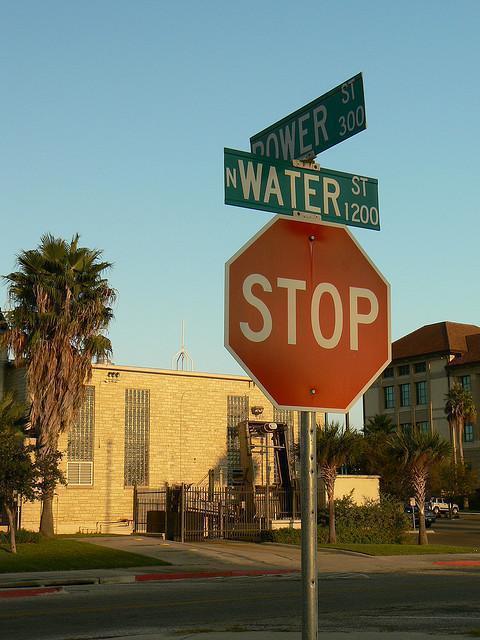What is next to the building?
Select the correct answer and articulate reasoning with the following format: 'Answer: answer
Rationale: rationale.'
Options: Trees, horse, antelope, cow. Answer: trees.
Rationale: The building is clearly visible and identifiable based on the outline and structure of the building. the objects next to it are also identifiable based on their unique features. 